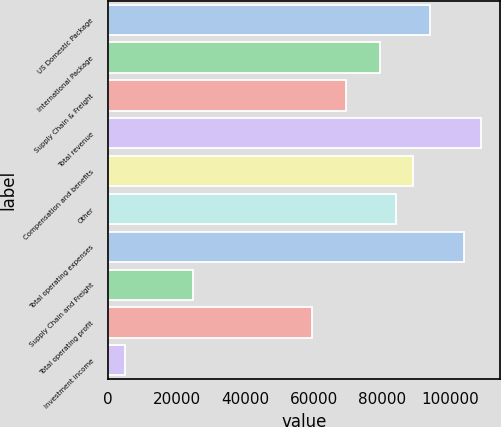Convert chart to OTSL. <chart><loc_0><loc_0><loc_500><loc_500><bar_chart><fcel>US Domestic Package<fcel>International Package<fcel>Supply Chain & Freight<fcel>Total revenue<fcel>Compensation and benefits<fcel>Other<fcel>Total operating expenses<fcel>Supply Chain and Freight<fcel>Total operating profit<fcel>Investment income<nl><fcel>94133.8<fcel>79270.8<fcel>69362.2<fcel>108997<fcel>89179.5<fcel>84225.1<fcel>104042<fcel>24773.4<fcel>59453.6<fcel>4956.19<nl></chart> 